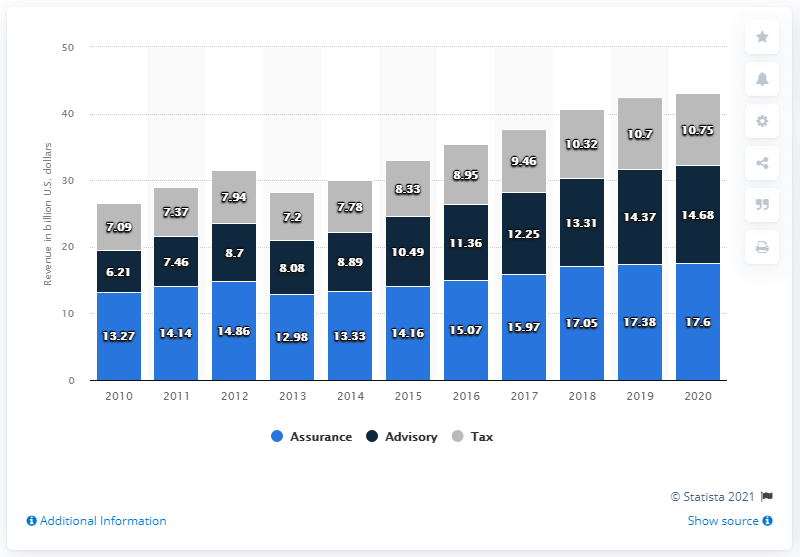List a handful of essential elements in this visual. PwC generated 17.6.. from its assurance services. 